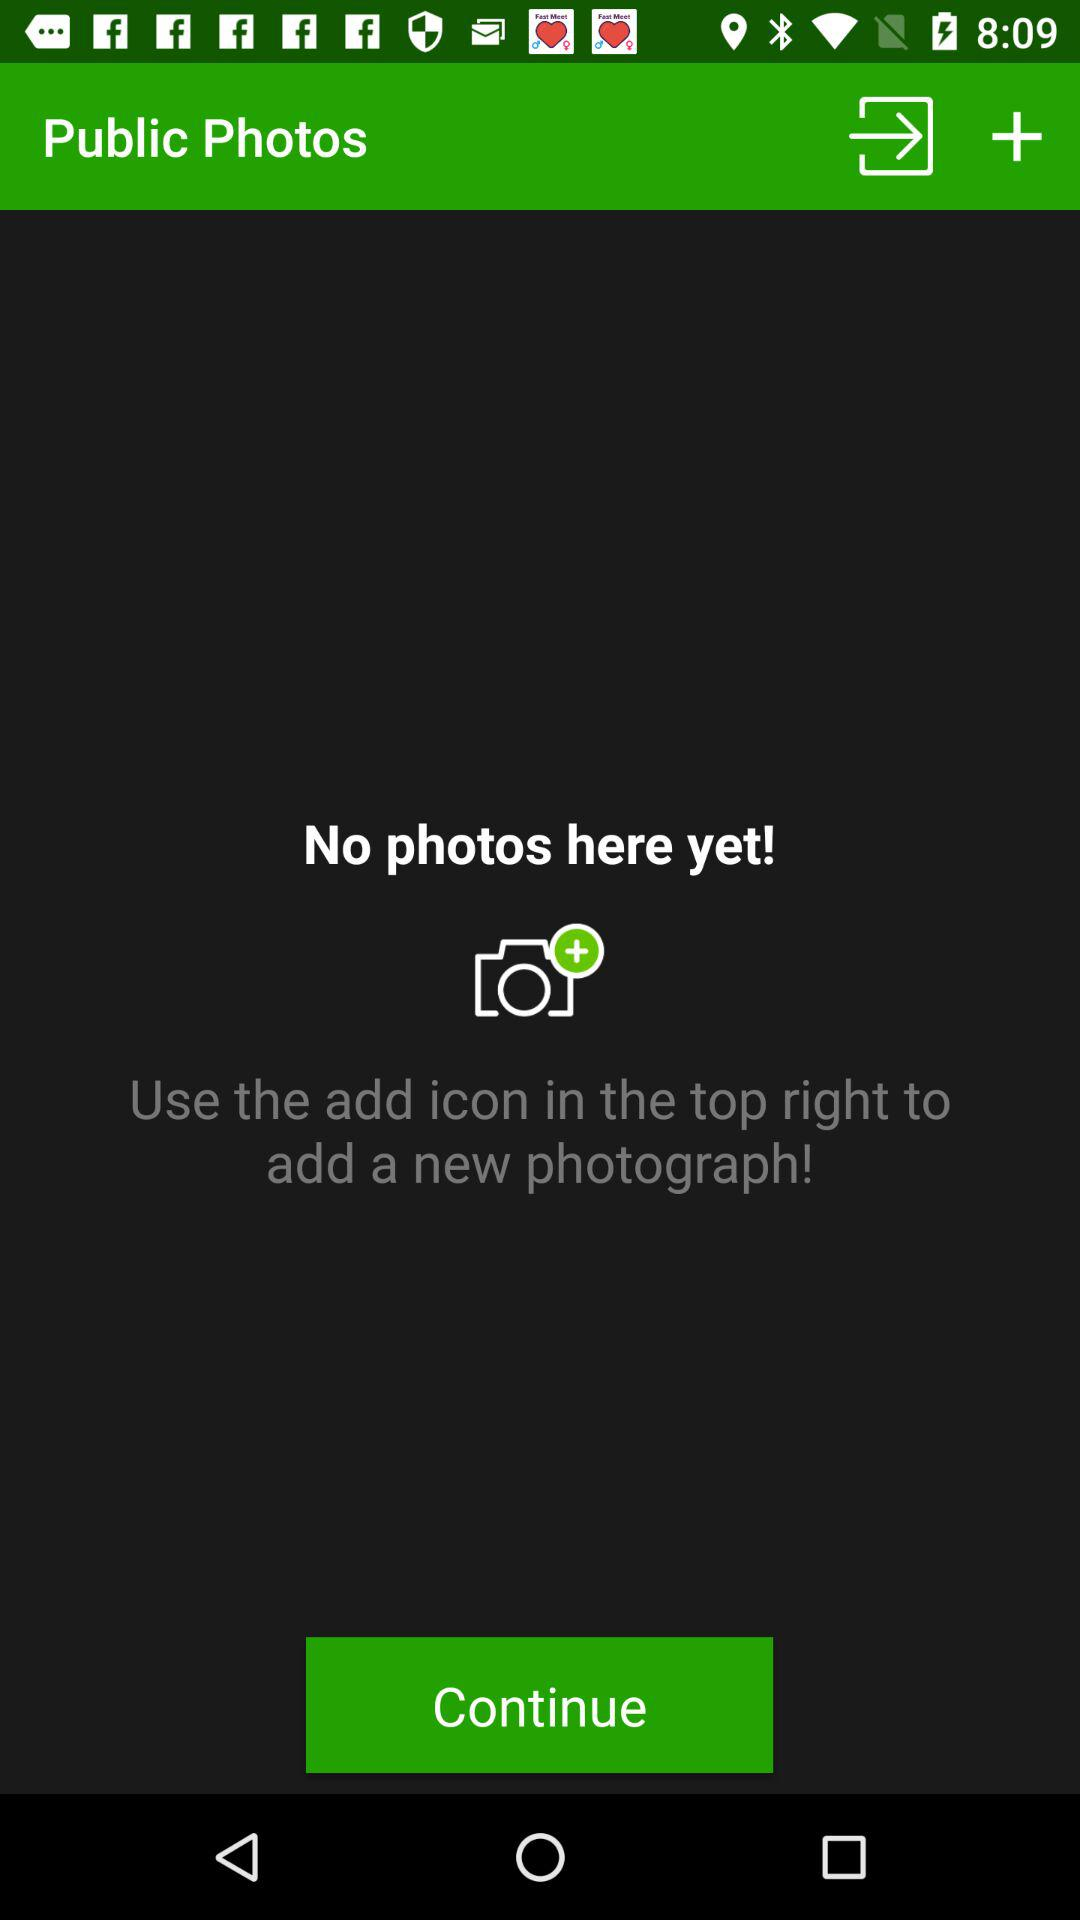Are there any photos? There are no photos. 